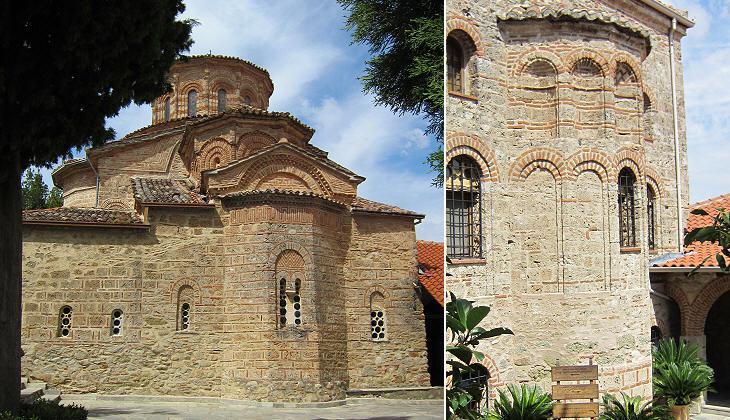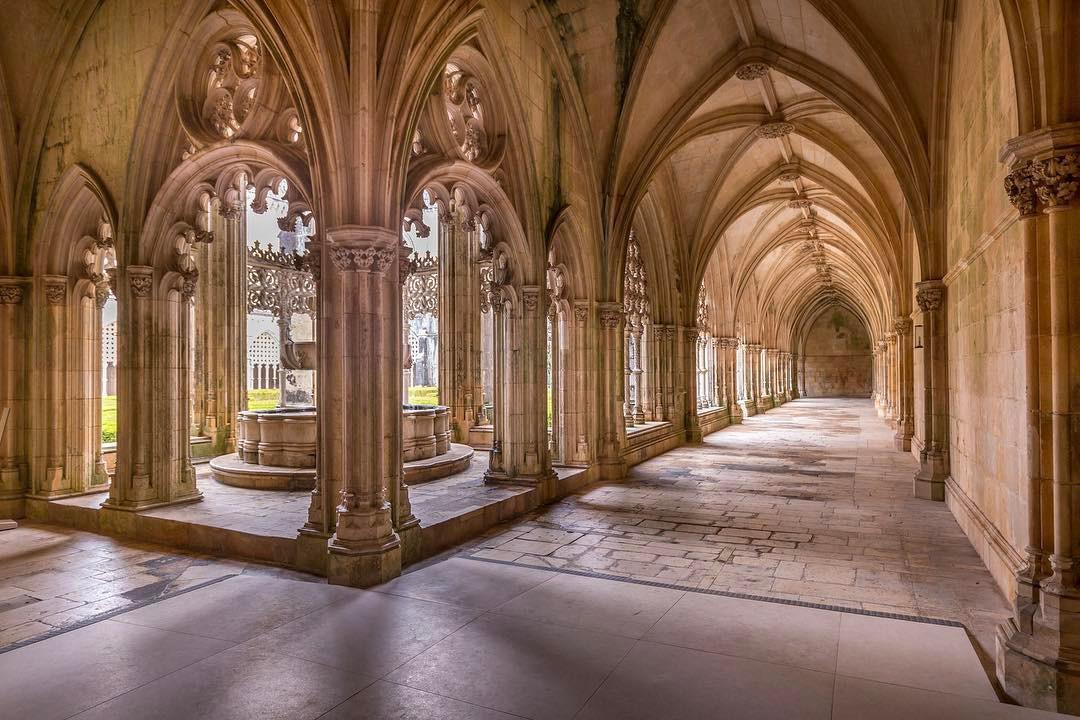The first image is the image on the left, the second image is the image on the right. Considering the images on both sides, is "In one image, a round fountain structure can be seen near long archway passages that run in two directions." valid? Answer yes or no. Yes. 